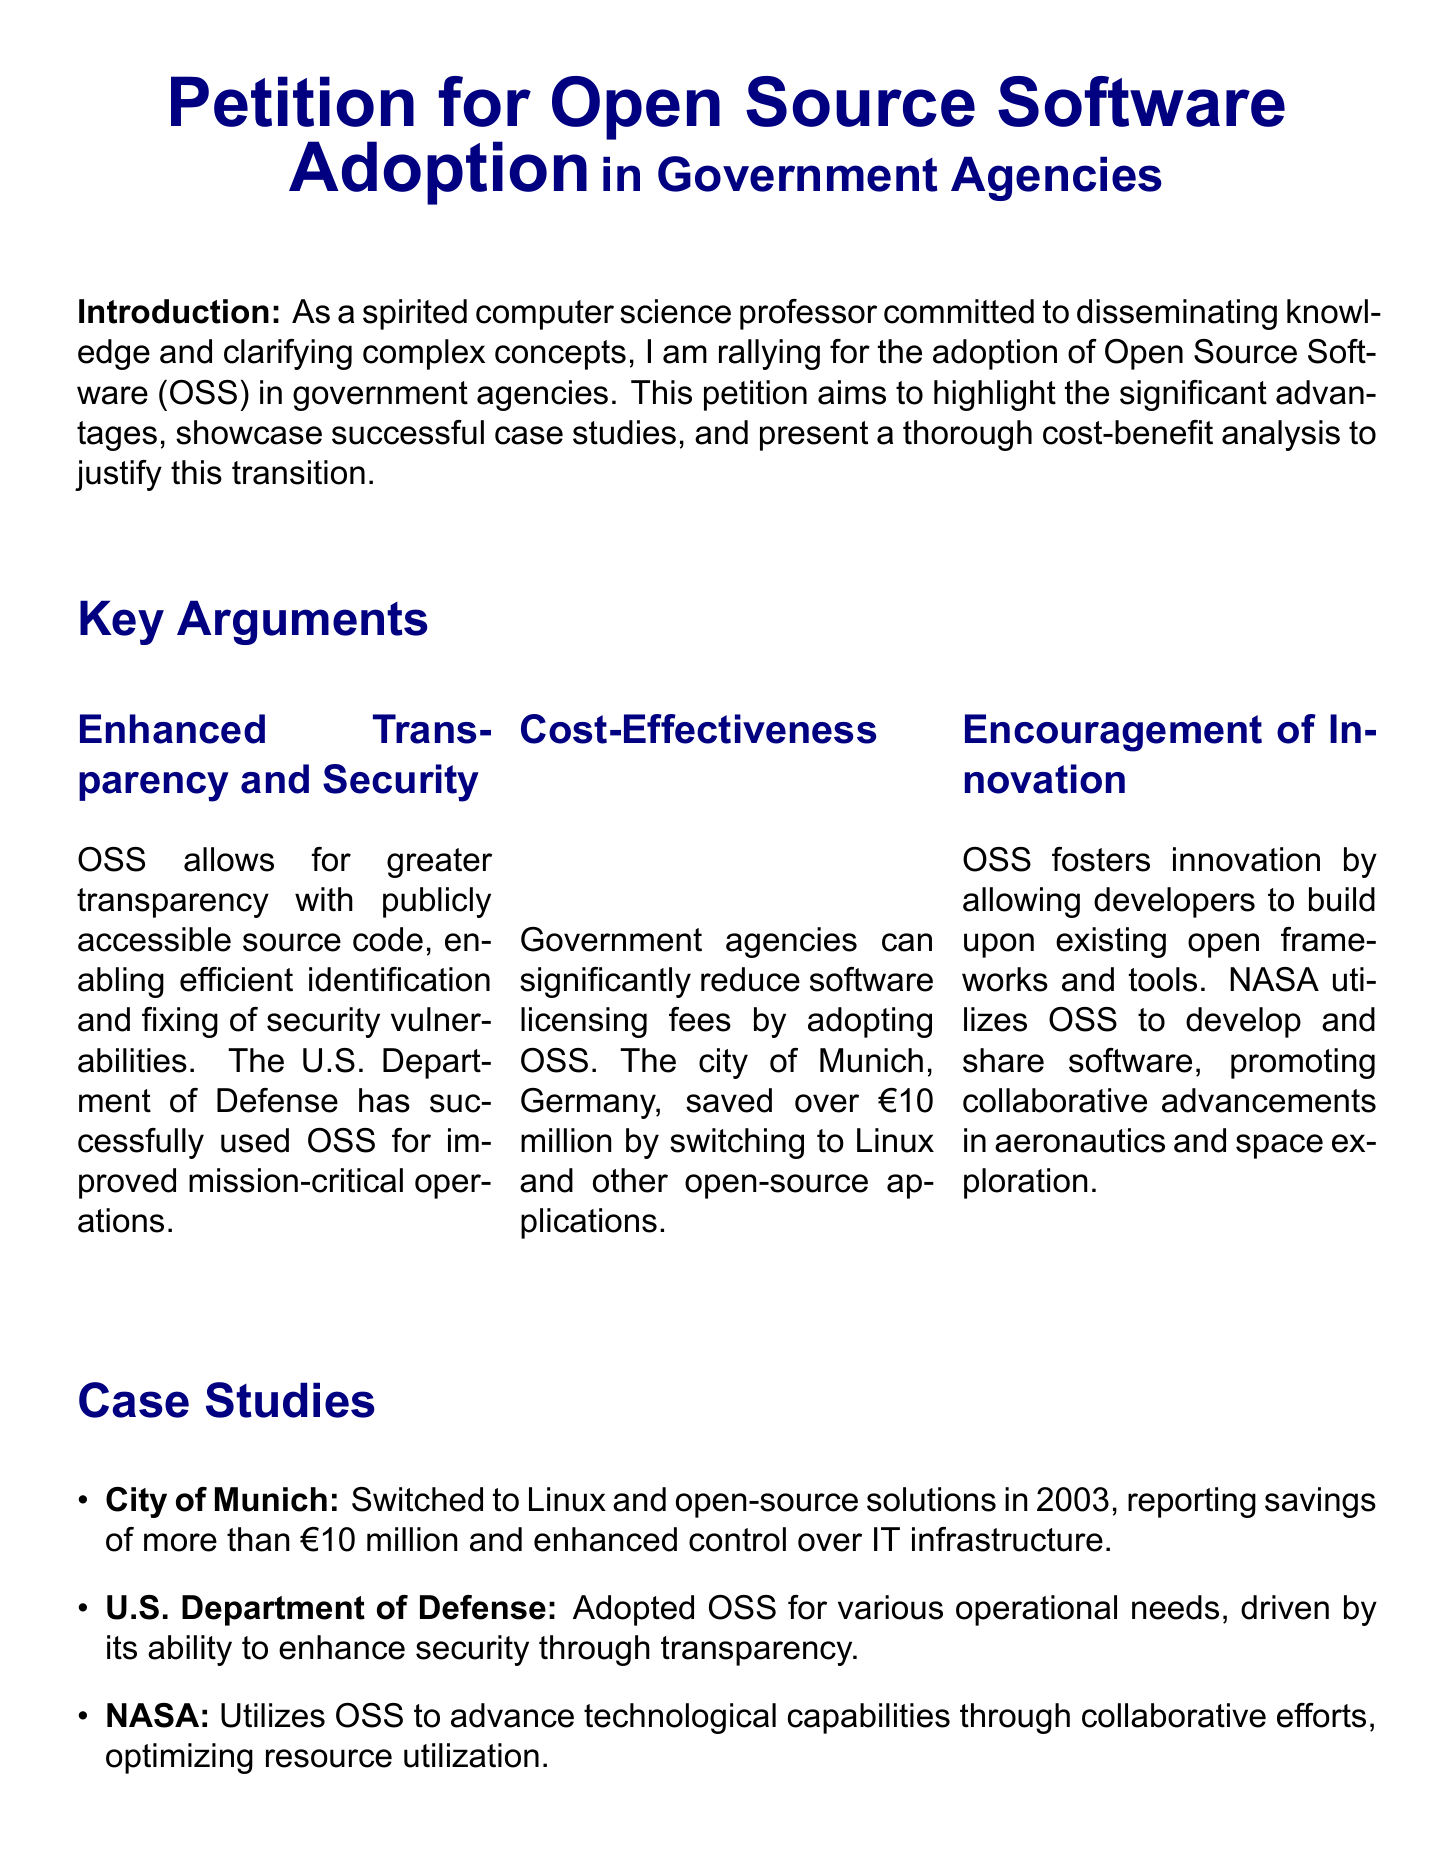what is the title of the petition? The title is prominently displayed at the top of the document, stating the purpose of the petition.
Answer: Petition for Open Source Software Adoption in Government Agencies who saved over €10 million by switching to open-source applications? The case study section details the success of a specific city in terms of savings associated with OSS adoption.
Answer: City of Munich what year did the City of Munich switch to Linux? The document provides a specific year when the transition to open-source solutions occurred.
Answer: 2003 which government agency utilizes OSS for aeronautics and space exploration? The document mentions a specific agency known for its advancements in technological capabilities using OSS.
Answer: NASA what is one of the key benefits of OSS according to the document? The key arguments section provides a concise list of benefits associated with OSS adoption.
Answer: Enhanced Transparency and Security what does TCO stand for in the context of the cost-benefit analysis? The cost-benefit analysis section includes an acronym that is explained within the text.
Answer: Total Cost of Ownership which department adopted OSS driven by security needs? A specific department is highlighted in the case studies as an adopter of OSS for security enhancements.
Answer: U.S. Department of Defense what are initial transition costs described as in the document? The document describes these costs while discussing the long-term financial implications of OSS adoption.
Answer: Elimination or significant reduction of licensing fees 